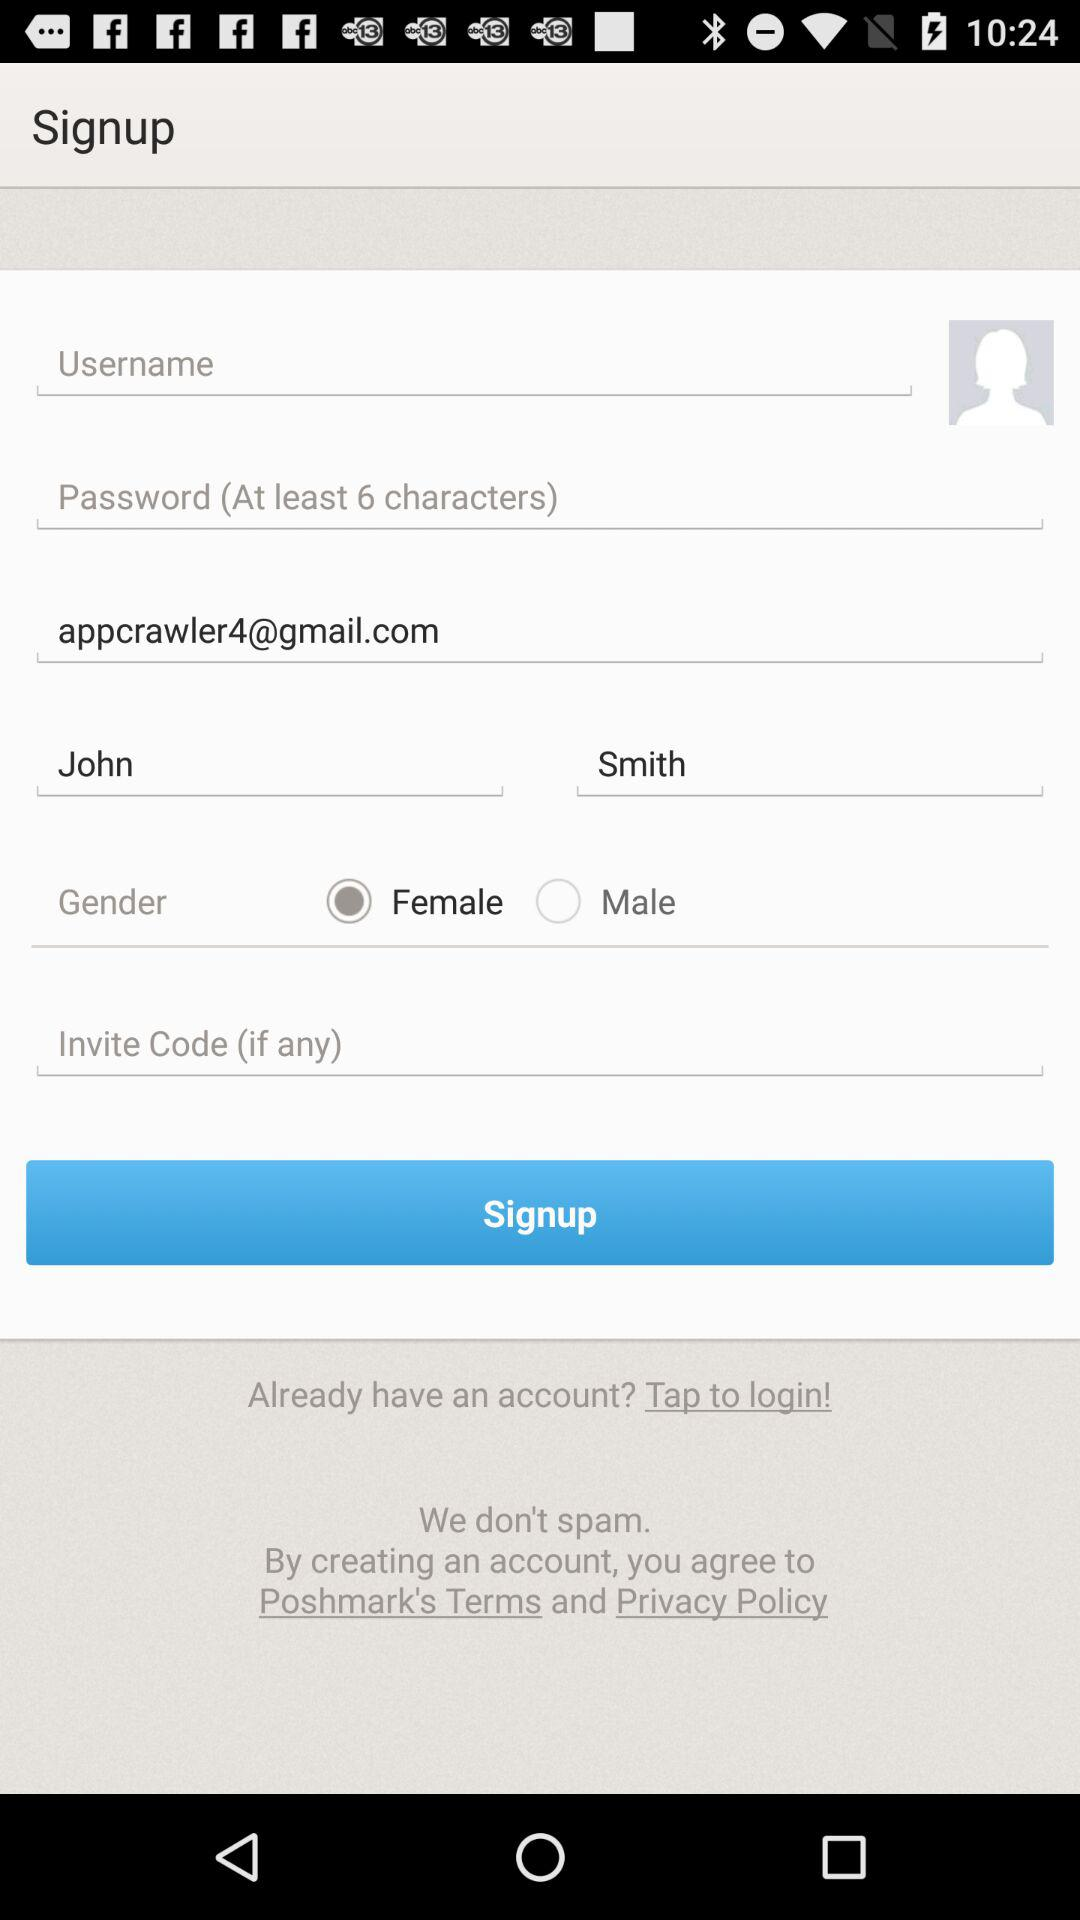How many numbers are required to create a password?
When the provided information is insufficient, respond with <no answer>. <no answer> 